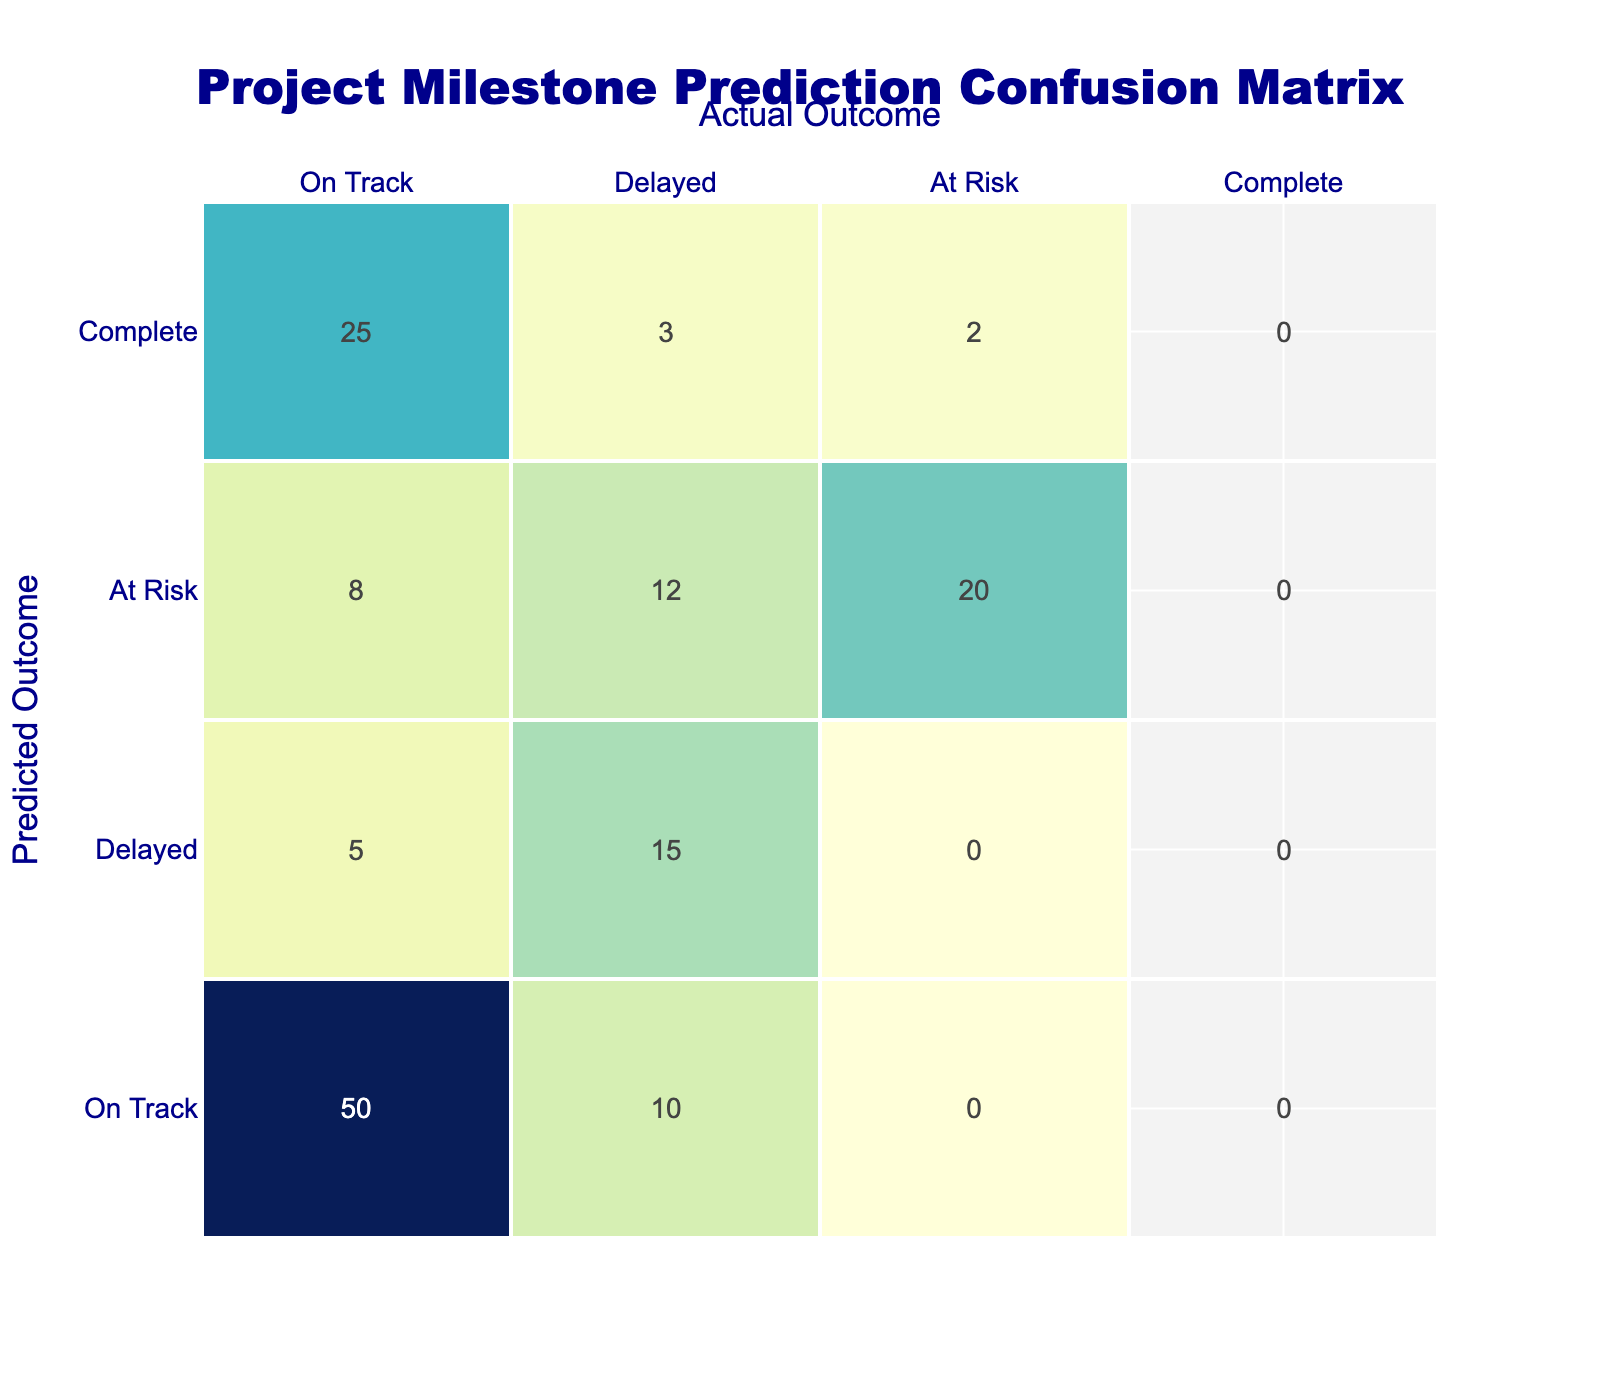What is the count of projects that were predicted to be "On Track" and actually were "Delayed"? The count of projects that were predicted to be "On Track" but were actually "Delayed" can be found in the table under the corresponding row and column. Looking at the table, the value at the intersection of "On Track" (predicted) and "Delayed" (actual) is 10.
Answer: 10 What is the total count of projects that were "Delayed"? To find the total count of projects that were "Delayed," we sum the counts from all rows where the actual outcome is "Delayed." This includes: 10 (predicted On Track), 15 (predicted Delayed), 12 (predicted At Risk), and 3 (predicted Complete). The total is 10 + 15 + 12 + 3 = 40.
Answer: 40 Is it true that more projects were "Complete" than "Delayed"? To determine the truth of this statement, we compare the counts. The total count of projects that were "Complete" is 25 (On Track) + 3 (Delayed) + 2 (At Risk) = 30. The total count for "Delayed" is 40, which is greater than 30. Hence, the statement is false.
Answer: No What is the count of projects predicted to be "At Risk" that were actually "On Track"? The count of projects predicted to be "At Risk" that were actually "On Track" corresponds to the intersection of the "At Risk" row and "On Track" column. The value in the table is 8, indicating that 8 projects fit this category.
Answer: 8 What is the difference between the number of projects predicted as "Complete" that ended up "Delayed" and those that were "On Track"? To find the difference, we identify the counts in the "Complete" row: 3 projects were "Delayed," and 25 projects were "On Track." The difference is calculated as 25 - 3 = 22.
Answer: 22 How many total projects were predicted as "Delayed"? To find the total projects predicted as "Delayed," we sum the counts from all rows where the predicted outcome is "Delayed." This includes: 5 (actually On Track), 15 (actually Delayed), 12 (actually At Risk). The total is 5 + 15 + 12 = 32.
Answer: 32 Which prediction outcome had the highest count in terms of actual "At Risk" projects? To find the prediction outcome with the highest count of actual "At Risk" projects, we look at the "At Risk" column for all predicted outcomes. The values are: 20 (predicted At Risk), 12 (predicted At Risk), and 2 (predicted Complete). The highest count is 20, which corresponds to the "At Risk" prediction.
Answer: 20 What percentage of projects predicted as "On Track" also remained "On Track"? To calculate the percentage, we take the count of projects that were both predicted and actually "On Track," which is 50, and divide it by the total projects predicted as "On Track." The total for "On Track" predictions is 50 + 10 + 8 + 25 (from the respective counts), which equals 93. The percentage is (50/93) * 100 ≈ 53.76%.
Answer: Approximately 53.76% 